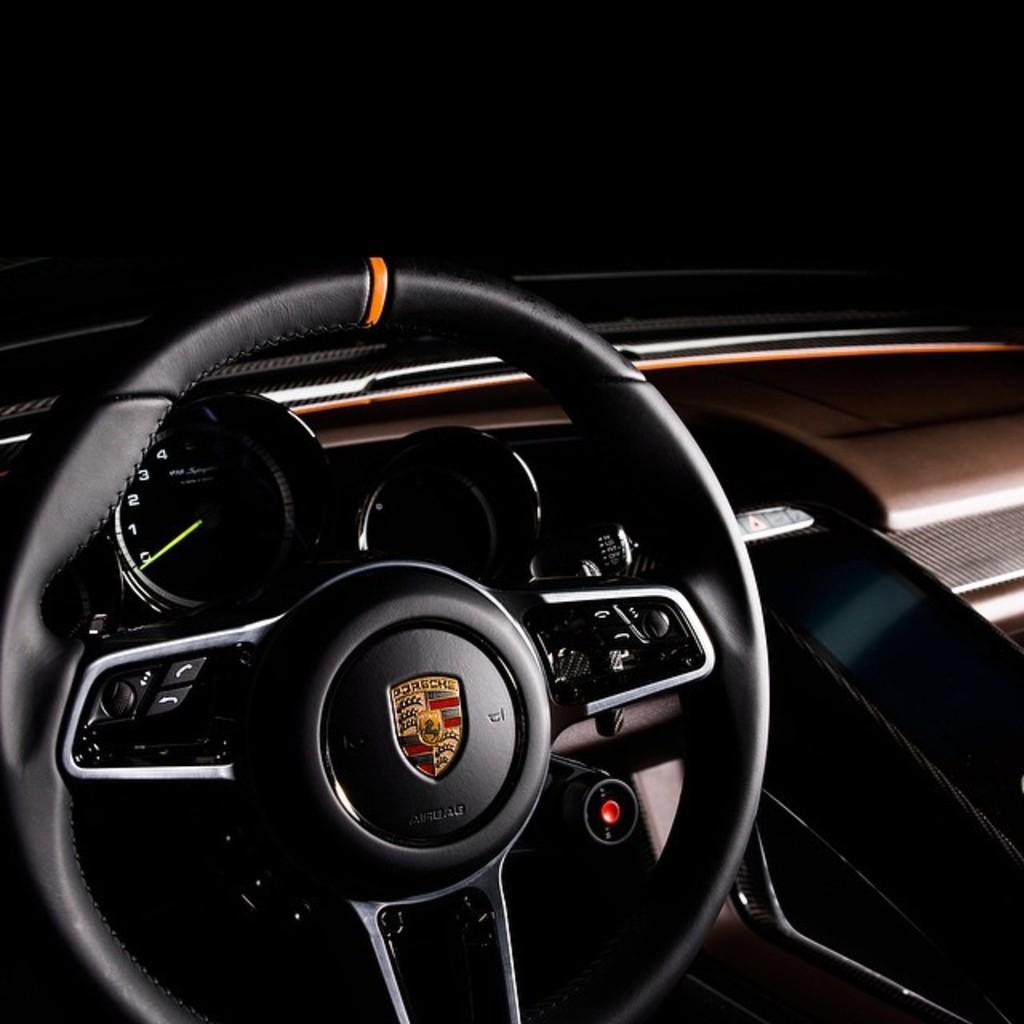In one or two sentences, can you explain what this image depicts? This picture is taken inside a vehicle. Left side there is a steering. Behind there is a meter indicator. 